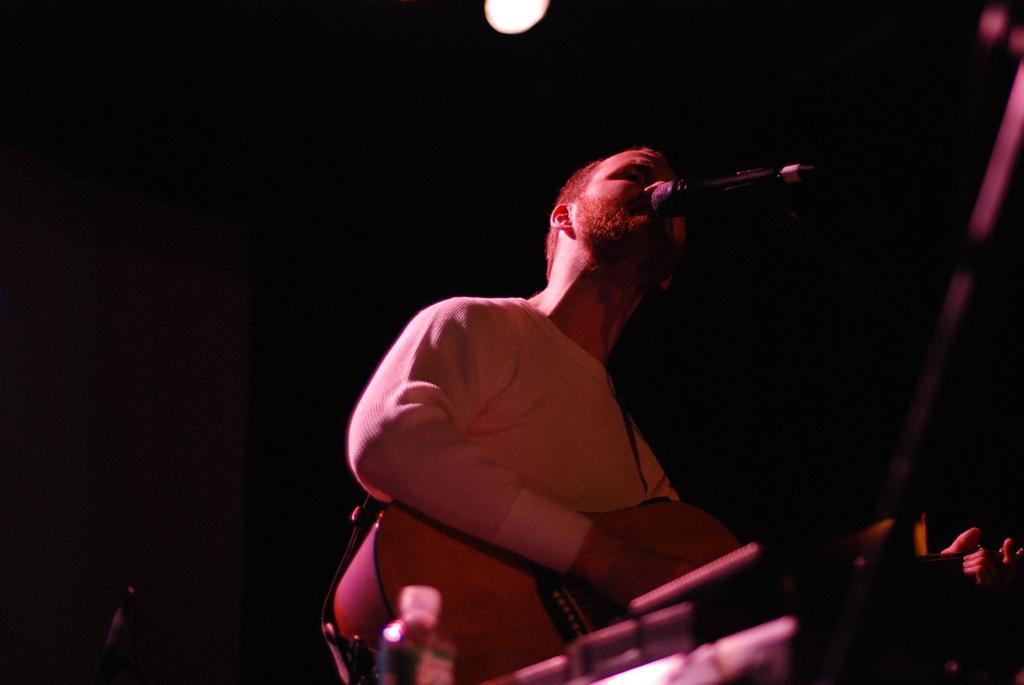In one or two sentences, can you explain what this image depicts? In this picture we can see a man is holding a guitar and singing a song. In front of the man there is a microphone, bottle and some objects. Behind the man there is the dark background and the light. 